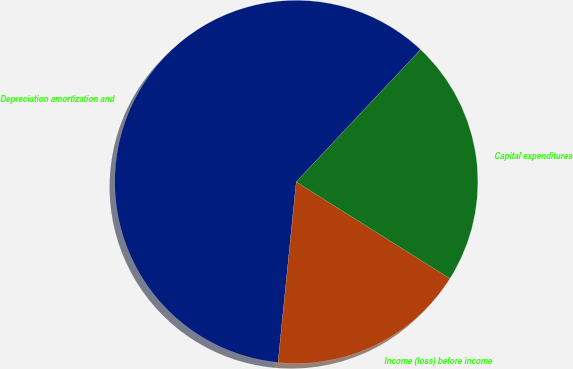Convert chart to OTSL. <chart><loc_0><loc_0><loc_500><loc_500><pie_chart><fcel>Depreciation amortization and<fcel>Income (loss) before income<fcel>Capital expenditures<nl><fcel>60.41%<fcel>17.66%<fcel>21.93%<nl></chart> 